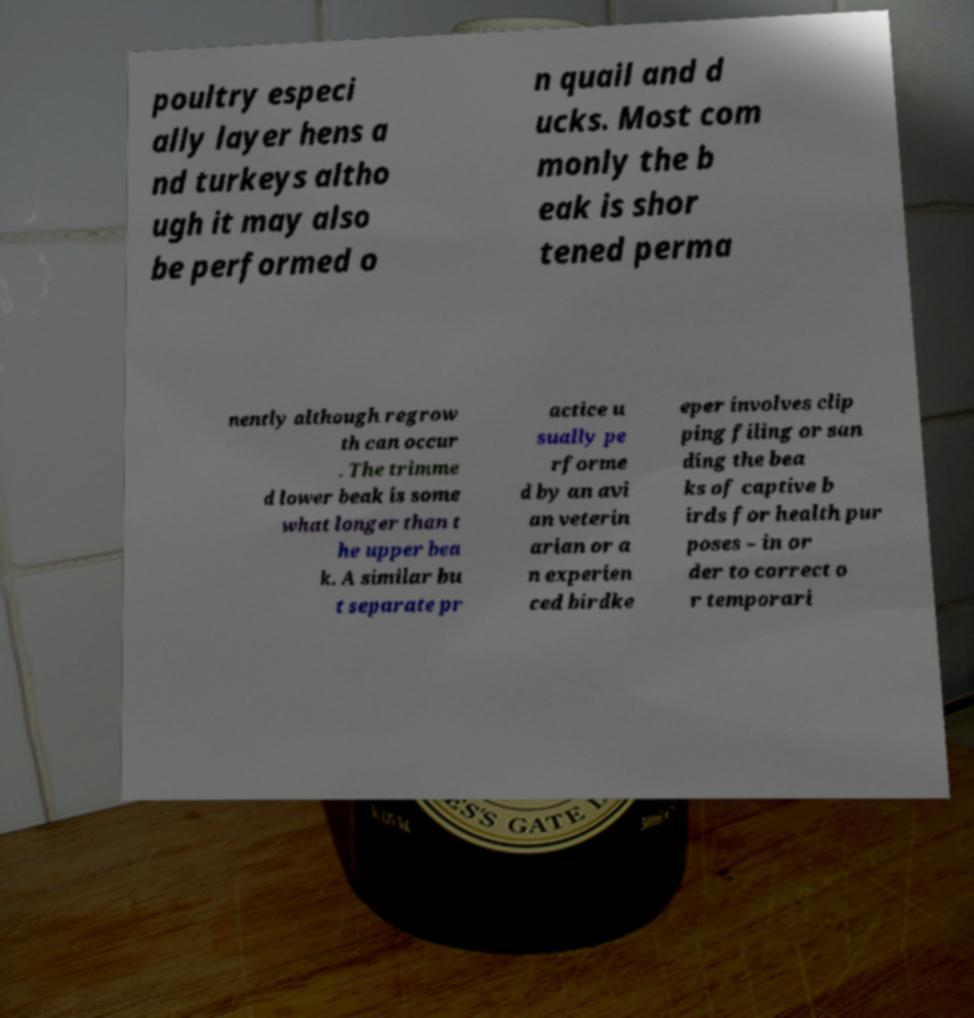Can you accurately transcribe the text from the provided image for me? poultry especi ally layer hens a nd turkeys altho ugh it may also be performed o n quail and d ucks. Most com monly the b eak is shor tened perma nently although regrow th can occur . The trimme d lower beak is some what longer than t he upper bea k. A similar bu t separate pr actice u sually pe rforme d by an avi an veterin arian or a n experien ced birdke eper involves clip ping filing or san ding the bea ks of captive b irds for health pur poses – in or der to correct o r temporari 